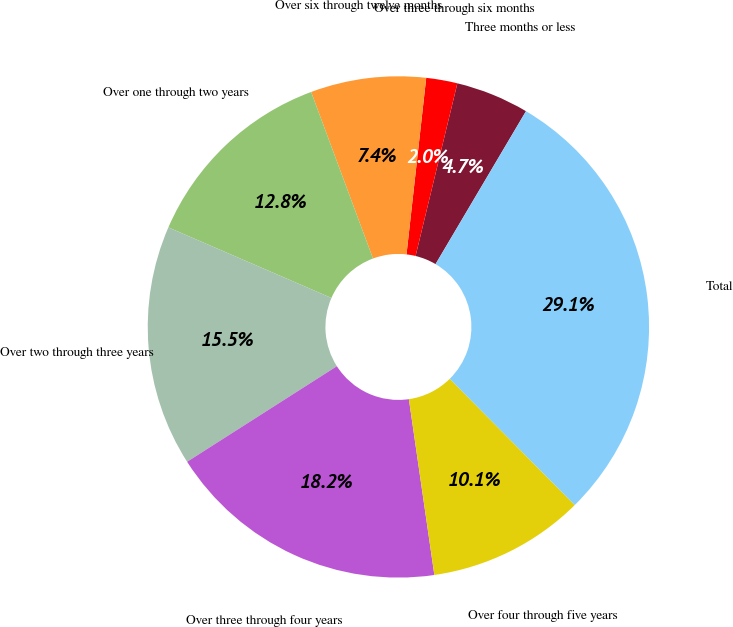Convert chart. <chart><loc_0><loc_0><loc_500><loc_500><pie_chart><fcel>Three months or less<fcel>Over three through six months<fcel>Over six through twelve months<fcel>Over one through two years<fcel>Over two through three years<fcel>Over three through four years<fcel>Over four through five years<fcel>Total<nl><fcel>4.72%<fcel>2.01%<fcel>7.43%<fcel>12.84%<fcel>15.54%<fcel>18.25%<fcel>10.13%<fcel>29.08%<nl></chart> 